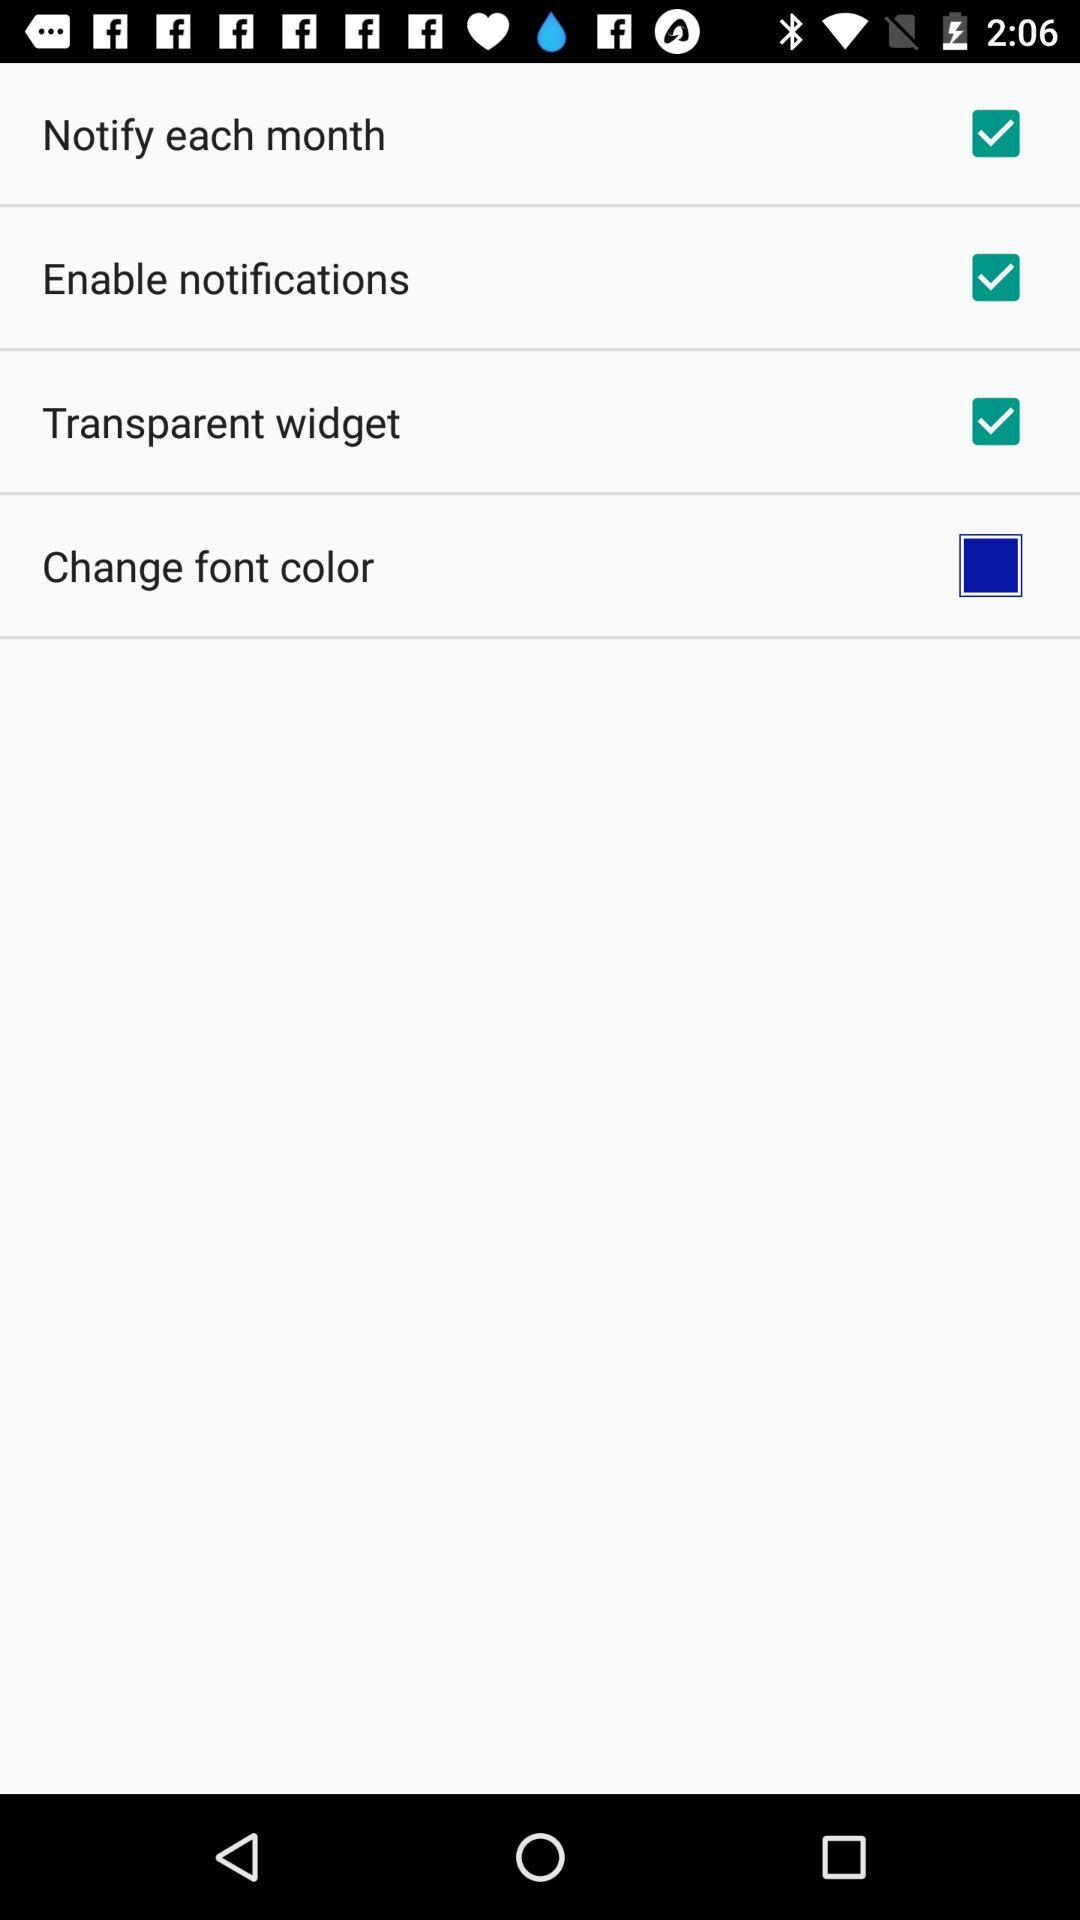What is the status of Notify each month? The status is on. 